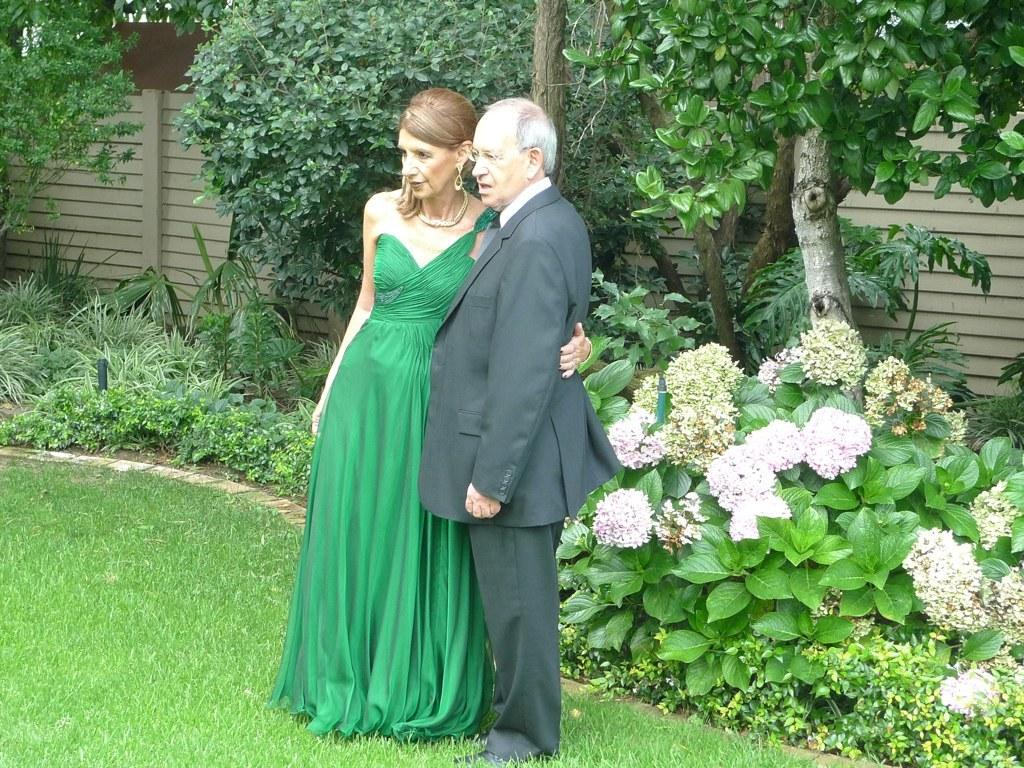What are the two people in the image wearing? The lady is wearing a green gown, and the guy is wearing a suit. What is the surface they are standing on? They are standing on the grass floor. What can be seen in the background of the image? There are trees and plants with flowers in the background. What type of sidewalk can be seen in the image? There is no sidewalk present in the image. What apparatus is being used by the lady in the green gown? There is no apparatus being used by the lady in the green gown in the image. 